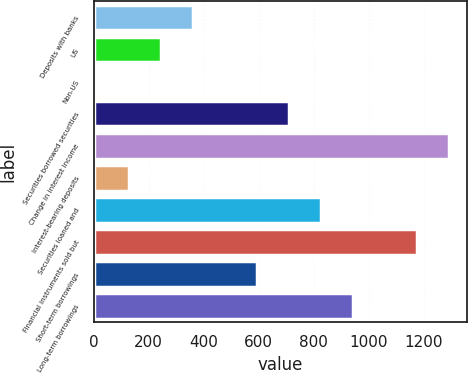Convert chart. <chart><loc_0><loc_0><loc_500><loc_500><bar_chart><fcel>Deposits with banks<fcel>US<fcel>Non-US<fcel>Securities borrowed securities<fcel>Change in interest income<fcel>Interest-bearing deposits<fcel>Securities loaned and<fcel>Financial instruments sold but<fcel>Short-term borrowings<fcel>Long-term borrowings<nl><fcel>360.5<fcel>244<fcel>11<fcel>710<fcel>1292.5<fcel>127.5<fcel>826.5<fcel>1176<fcel>593.5<fcel>943<nl></chart> 